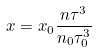<formula> <loc_0><loc_0><loc_500><loc_500>x = x _ { 0 } \frac { n \tau ^ { 3 } } { n _ { 0 } \tau _ { 0 } ^ { 3 } }</formula> 